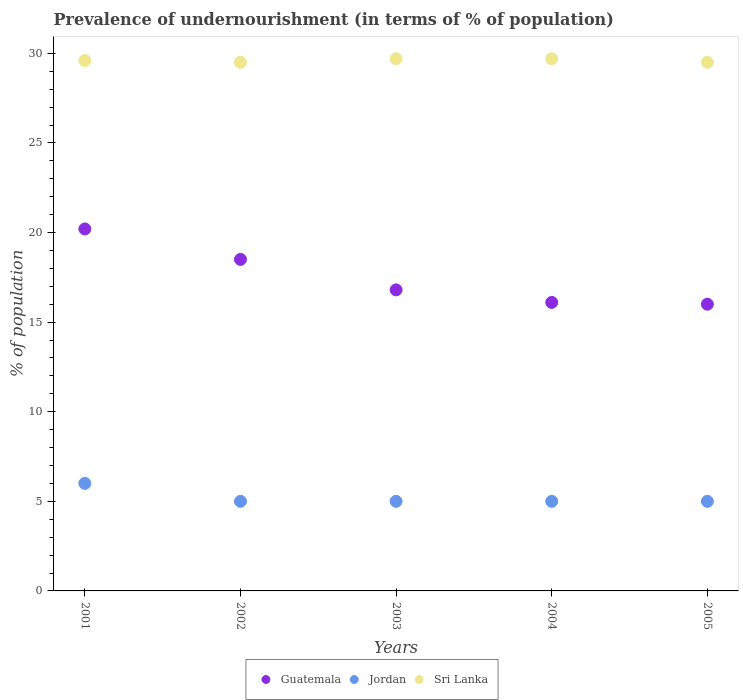How many different coloured dotlines are there?
Offer a very short reply. 3. Across all years, what is the maximum percentage of undernourished population in Sri Lanka?
Ensure brevity in your answer.  29.7. Across all years, what is the minimum percentage of undernourished population in Guatemala?
Ensure brevity in your answer.  16. In which year was the percentage of undernourished population in Jordan maximum?
Make the answer very short. 2001. What is the total percentage of undernourished population in Guatemala in the graph?
Make the answer very short. 87.6. What is the difference between the percentage of undernourished population in Guatemala in 2001 and that in 2005?
Offer a very short reply. 4.2. What is the difference between the percentage of undernourished population in Jordan in 2004 and the percentage of undernourished population in Sri Lanka in 2003?
Your answer should be very brief. -24.7. What is the average percentage of undernourished population in Guatemala per year?
Provide a short and direct response. 17.52. In the year 2004, what is the difference between the percentage of undernourished population in Jordan and percentage of undernourished population in Guatemala?
Your answer should be very brief. -11.1. What is the difference between the highest and the lowest percentage of undernourished population in Sri Lanka?
Offer a terse response. 0.2. In how many years, is the percentage of undernourished population in Jordan greater than the average percentage of undernourished population in Jordan taken over all years?
Your answer should be very brief. 1. Is the sum of the percentage of undernourished population in Jordan in 2002 and 2004 greater than the maximum percentage of undernourished population in Sri Lanka across all years?
Give a very brief answer. No. Is the percentage of undernourished population in Sri Lanka strictly greater than the percentage of undernourished population in Guatemala over the years?
Offer a very short reply. Yes. How many dotlines are there?
Make the answer very short. 3. Are the values on the major ticks of Y-axis written in scientific E-notation?
Your answer should be very brief. No. Does the graph contain any zero values?
Offer a very short reply. No. Does the graph contain grids?
Ensure brevity in your answer.  No. Where does the legend appear in the graph?
Give a very brief answer. Bottom center. How many legend labels are there?
Your response must be concise. 3. How are the legend labels stacked?
Offer a very short reply. Horizontal. What is the title of the graph?
Provide a succinct answer. Prevalence of undernourishment (in terms of % of population). What is the label or title of the Y-axis?
Provide a succinct answer. % of population. What is the % of population in Guatemala in 2001?
Provide a succinct answer. 20.2. What is the % of population of Sri Lanka in 2001?
Your answer should be compact. 29.6. What is the % of population of Guatemala in 2002?
Offer a very short reply. 18.5. What is the % of population in Jordan in 2002?
Give a very brief answer. 5. What is the % of population in Sri Lanka in 2002?
Make the answer very short. 29.5. What is the % of population of Guatemala in 2003?
Make the answer very short. 16.8. What is the % of population of Jordan in 2003?
Offer a very short reply. 5. What is the % of population of Sri Lanka in 2003?
Your answer should be very brief. 29.7. What is the % of population of Sri Lanka in 2004?
Provide a short and direct response. 29.7. What is the % of population of Jordan in 2005?
Your answer should be compact. 5. What is the % of population in Sri Lanka in 2005?
Give a very brief answer. 29.5. Across all years, what is the maximum % of population of Guatemala?
Make the answer very short. 20.2. Across all years, what is the maximum % of population in Jordan?
Offer a very short reply. 6. Across all years, what is the maximum % of population of Sri Lanka?
Provide a short and direct response. 29.7. Across all years, what is the minimum % of population in Jordan?
Offer a terse response. 5. Across all years, what is the minimum % of population in Sri Lanka?
Make the answer very short. 29.5. What is the total % of population in Guatemala in the graph?
Give a very brief answer. 87.6. What is the total % of population in Jordan in the graph?
Keep it short and to the point. 26. What is the total % of population in Sri Lanka in the graph?
Provide a succinct answer. 148. What is the difference between the % of population in Sri Lanka in 2001 and that in 2002?
Your answer should be very brief. 0.1. What is the difference between the % of population of Guatemala in 2001 and that in 2003?
Give a very brief answer. 3.4. What is the difference between the % of population in Guatemala in 2001 and that in 2004?
Give a very brief answer. 4.1. What is the difference between the % of population of Sri Lanka in 2001 and that in 2004?
Offer a terse response. -0.1. What is the difference between the % of population in Guatemala in 2001 and that in 2005?
Ensure brevity in your answer.  4.2. What is the difference between the % of population in Guatemala in 2002 and that in 2003?
Your answer should be very brief. 1.7. What is the difference between the % of population in Jordan in 2002 and that in 2003?
Ensure brevity in your answer.  0. What is the difference between the % of population of Jordan in 2002 and that in 2005?
Offer a very short reply. 0. What is the difference between the % of population in Guatemala in 2003 and that in 2004?
Your answer should be compact. 0.7. What is the difference between the % of population of Jordan in 2003 and that in 2005?
Provide a short and direct response. 0. What is the difference between the % of population in Jordan in 2004 and that in 2005?
Your answer should be very brief. 0. What is the difference between the % of population of Sri Lanka in 2004 and that in 2005?
Your answer should be very brief. 0.2. What is the difference between the % of population in Jordan in 2001 and the % of population in Sri Lanka in 2002?
Ensure brevity in your answer.  -23.5. What is the difference between the % of population of Guatemala in 2001 and the % of population of Jordan in 2003?
Provide a short and direct response. 15.2. What is the difference between the % of population of Jordan in 2001 and the % of population of Sri Lanka in 2003?
Give a very brief answer. -23.7. What is the difference between the % of population in Jordan in 2001 and the % of population in Sri Lanka in 2004?
Provide a succinct answer. -23.7. What is the difference between the % of population of Guatemala in 2001 and the % of population of Jordan in 2005?
Make the answer very short. 15.2. What is the difference between the % of population in Guatemala in 2001 and the % of population in Sri Lanka in 2005?
Give a very brief answer. -9.3. What is the difference between the % of population of Jordan in 2001 and the % of population of Sri Lanka in 2005?
Ensure brevity in your answer.  -23.5. What is the difference between the % of population of Guatemala in 2002 and the % of population of Jordan in 2003?
Your response must be concise. 13.5. What is the difference between the % of population in Guatemala in 2002 and the % of population in Sri Lanka in 2003?
Make the answer very short. -11.2. What is the difference between the % of population of Jordan in 2002 and the % of population of Sri Lanka in 2003?
Make the answer very short. -24.7. What is the difference between the % of population of Guatemala in 2002 and the % of population of Jordan in 2004?
Your response must be concise. 13.5. What is the difference between the % of population of Jordan in 2002 and the % of population of Sri Lanka in 2004?
Provide a succinct answer. -24.7. What is the difference between the % of population of Guatemala in 2002 and the % of population of Jordan in 2005?
Your answer should be very brief. 13.5. What is the difference between the % of population of Guatemala in 2002 and the % of population of Sri Lanka in 2005?
Provide a succinct answer. -11. What is the difference between the % of population of Jordan in 2002 and the % of population of Sri Lanka in 2005?
Offer a very short reply. -24.5. What is the difference between the % of population in Guatemala in 2003 and the % of population in Sri Lanka in 2004?
Provide a short and direct response. -12.9. What is the difference between the % of population in Jordan in 2003 and the % of population in Sri Lanka in 2004?
Your answer should be very brief. -24.7. What is the difference between the % of population of Jordan in 2003 and the % of population of Sri Lanka in 2005?
Keep it short and to the point. -24.5. What is the difference between the % of population in Guatemala in 2004 and the % of population in Sri Lanka in 2005?
Your answer should be compact. -13.4. What is the difference between the % of population of Jordan in 2004 and the % of population of Sri Lanka in 2005?
Provide a short and direct response. -24.5. What is the average % of population of Guatemala per year?
Offer a terse response. 17.52. What is the average % of population of Jordan per year?
Offer a very short reply. 5.2. What is the average % of population in Sri Lanka per year?
Your answer should be compact. 29.6. In the year 2001, what is the difference between the % of population in Guatemala and % of population in Sri Lanka?
Your answer should be compact. -9.4. In the year 2001, what is the difference between the % of population in Jordan and % of population in Sri Lanka?
Provide a succinct answer. -23.6. In the year 2002, what is the difference between the % of population in Guatemala and % of population in Sri Lanka?
Provide a short and direct response. -11. In the year 2002, what is the difference between the % of population of Jordan and % of population of Sri Lanka?
Ensure brevity in your answer.  -24.5. In the year 2003, what is the difference between the % of population in Guatemala and % of population in Jordan?
Provide a short and direct response. 11.8. In the year 2003, what is the difference between the % of population in Guatemala and % of population in Sri Lanka?
Offer a very short reply. -12.9. In the year 2003, what is the difference between the % of population of Jordan and % of population of Sri Lanka?
Your response must be concise. -24.7. In the year 2004, what is the difference between the % of population in Jordan and % of population in Sri Lanka?
Your answer should be compact. -24.7. In the year 2005, what is the difference between the % of population in Guatemala and % of population in Jordan?
Provide a short and direct response. 11. In the year 2005, what is the difference between the % of population in Jordan and % of population in Sri Lanka?
Make the answer very short. -24.5. What is the ratio of the % of population of Guatemala in 2001 to that in 2002?
Provide a short and direct response. 1.09. What is the ratio of the % of population of Guatemala in 2001 to that in 2003?
Give a very brief answer. 1.2. What is the ratio of the % of population in Guatemala in 2001 to that in 2004?
Provide a short and direct response. 1.25. What is the ratio of the % of population of Jordan in 2001 to that in 2004?
Provide a succinct answer. 1.2. What is the ratio of the % of population in Guatemala in 2001 to that in 2005?
Offer a very short reply. 1.26. What is the ratio of the % of population of Jordan in 2001 to that in 2005?
Make the answer very short. 1.2. What is the ratio of the % of population of Guatemala in 2002 to that in 2003?
Your answer should be very brief. 1.1. What is the ratio of the % of population in Jordan in 2002 to that in 2003?
Offer a very short reply. 1. What is the ratio of the % of population in Guatemala in 2002 to that in 2004?
Ensure brevity in your answer.  1.15. What is the ratio of the % of population of Jordan in 2002 to that in 2004?
Your response must be concise. 1. What is the ratio of the % of population of Sri Lanka in 2002 to that in 2004?
Provide a short and direct response. 0.99. What is the ratio of the % of population in Guatemala in 2002 to that in 2005?
Offer a very short reply. 1.16. What is the ratio of the % of population of Guatemala in 2003 to that in 2004?
Make the answer very short. 1.04. What is the ratio of the % of population of Jordan in 2003 to that in 2004?
Make the answer very short. 1. What is the ratio of the % of population in Guatemala in 2003 to that in 2005?
Your answer should be compact. 1.05. What is the ratio of the % of population in Jordan in 2003 to that in 2005?
Make the answer very short. 1. What is the ratio of the % of population in Sri Lanka in 2003 to that in 2005?
Offer a terse response. 1.01. What is the ratio of the % of population of Guatemala in 2004 to that in 2005?
Make the answer very short. 1.01. What is the ratio of the % of population of Jordan in 2004 to that in 2005?
Give a very brief answer. 1. What is the ratio of the % of population in Sri Lanka in 2004 to that in 2005?
Make the answer very short. 1.01. What is the difference between the highest and the second highest % of population in Guatemala?
Offer a terse response. 1.7. What is the difference between the highest and the second highest % of population in Jordan?
Your response must be concise. 1. What is the difference between the highest and the lowest % of population in Guatemala?
Make the answer very short. 4.2. 